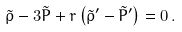<formula> <loc_0><loc_0><loc_500><loc_500>\tilde { \rho } - 3 \tilde { P } + r \left ( \tilde { \rho } ^ { \prime } - \tilde { P } ^ { \prime } \right ) = 0 \, .</formula> 